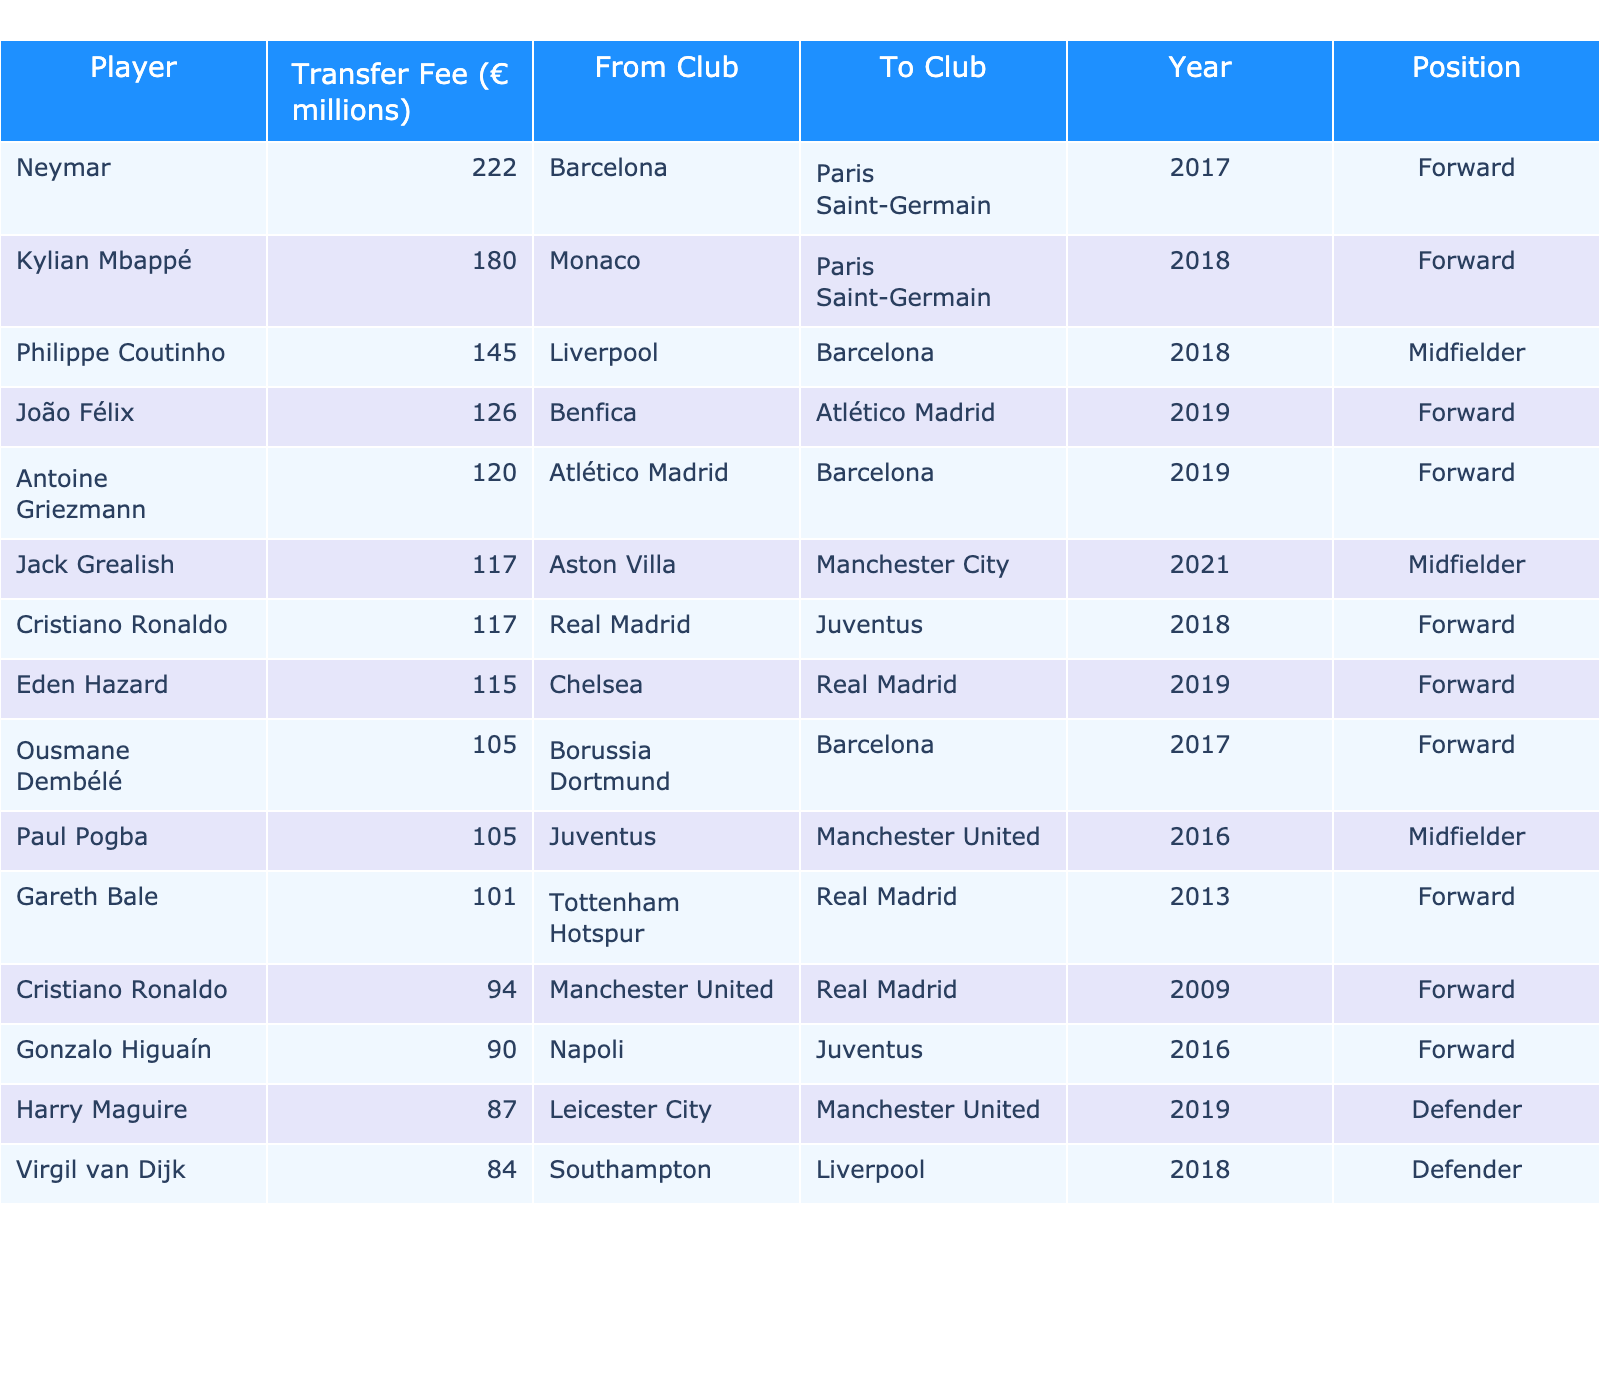What is the highest transfer fee recorded in the table? The table lists multiple player transfer fees, and by scanning through the data, it's clear that Neymar's transfer fee of 222 million euros is the highest.
Answer: 222 million euros Which player was transferred from Liverpool to Barcelona and for how much? By reviewing the table, I can identify that Philippe Coutinho was transferred from Liverpool to Barcelona for a fee of 145 million euros.
Answer: Philippe Coutinho for 145 million euros How many players were transferred for more than 100 million euros? I observe the table and count the players whose transfer fees exceed 100 million euros. These players are Neymar, Kylian Mbappé, Philippe Coutinho, João Félix, Antoine Griezmann, Jack Grealish, and Eden Hazard, totaling 7 players.
Answer: 7 players What is the average transfer fee of the players listed in the table? To find the average, I first sum all the transfer fees: 222 + 180 + 145 + 126 + 120 + 117 + 117 + 115 + 105 + 105 + 101 + 94 + 90 + 87 + 84 = 1,770 million euros. There are 15 players, so I divide 1,770 by 15, resulting in an average of 118 million euros.
Answer: 118 million euros Is it true that all players listed in the table were forwards? By examining the positions in the table, I find that not all players are forwards; specifically, there are midfielders and defenders included as well.
Answer: No Which club received the highest fee from a player transfer? Analyzing the 'From Club' and 'Transfer Fee' columns, I see that Barcelona received the highest fee for Neymar's transfer to PSG, totaling 222 million euros.
Answer: Barcelona with 222 million euros What is the difference in transfer fees between the most expensive and the least expensive players in the table? The most expensive transfer is Neymar at 222 million euros and the least expensive is Harry Maguire at 87 million euros. The difference is 222 - 87 = 135 million euros.
Answer: 135 million euros How many players moved to Paris Saint-Germain, and what were their transfer fees? Looking at the 'To Club' column, I identify two players who moved to Paris Saint-Germain: Neymar for 222 million euros and Kylian Mbappé for 180 million euros, therefore totaling 402 million euros.
Answer: 2 players for 402 million euros Which year saw the highest number of transfers, according to the table? By reviewing the 'Year' column, I identify that both 2018 and 2019 have multiple entries. 2018 has 4 transfers: Neymar, Kylian Mbappé, and Cristiano Ronaldo, while 2019 has 4 transfers: João Félix, Antoine Griezmann, Eden Hazard, and one other. They are equal in quantity.
Answer: 2018 and 2019 both with 4 transfers Who is the only defender in the table and what was his transfer fee? Scanning through the 'Position' column, I find that Harry Maguire is listed as a defender with a transfer fee of 87 million euros.
Answer: Harry Maguire for 87 million euros 